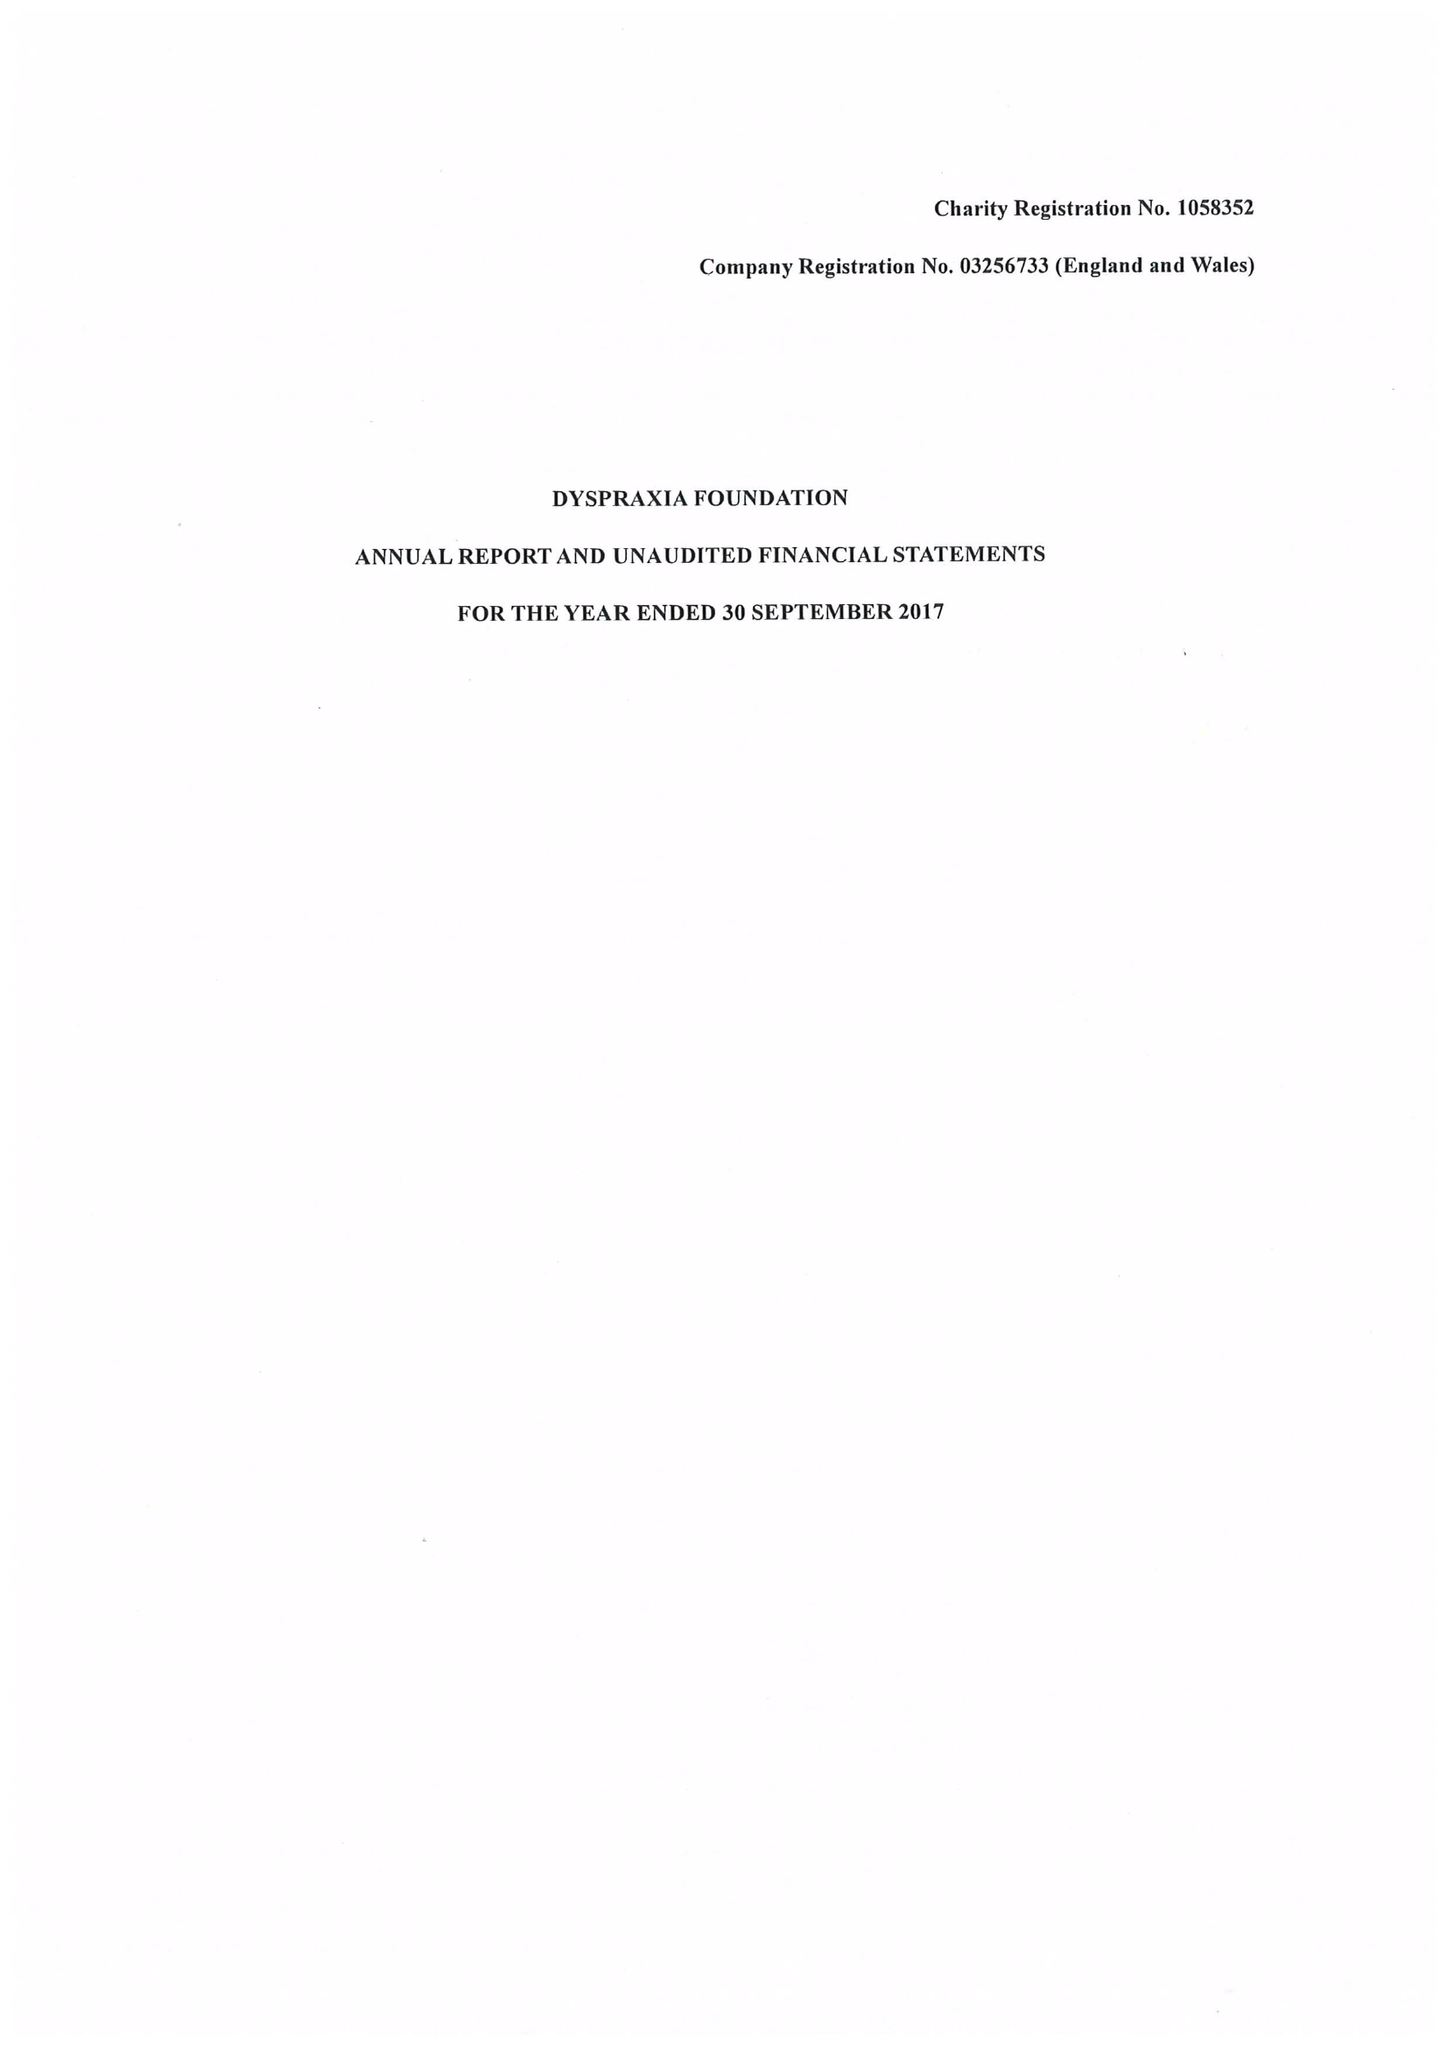What is the value for the charity_name?
Answer the question using a single word or phrase. Dyspraxia Foundation 